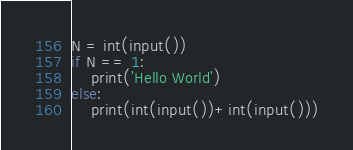<code> <loc_0><loc_0><loc_500><loc_500><_Python_>N = int(input())
if N == 1:
    print('Hello World')
else:
    print(int(input())+int(input()))</code> 